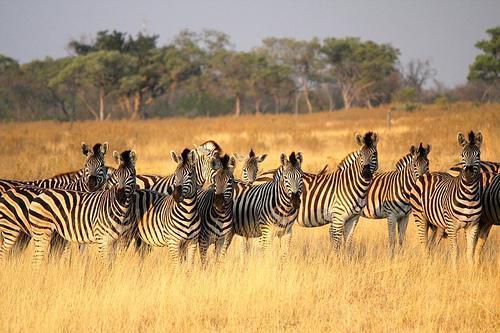How many zebras are there?
Give a very brief answer. 13. 